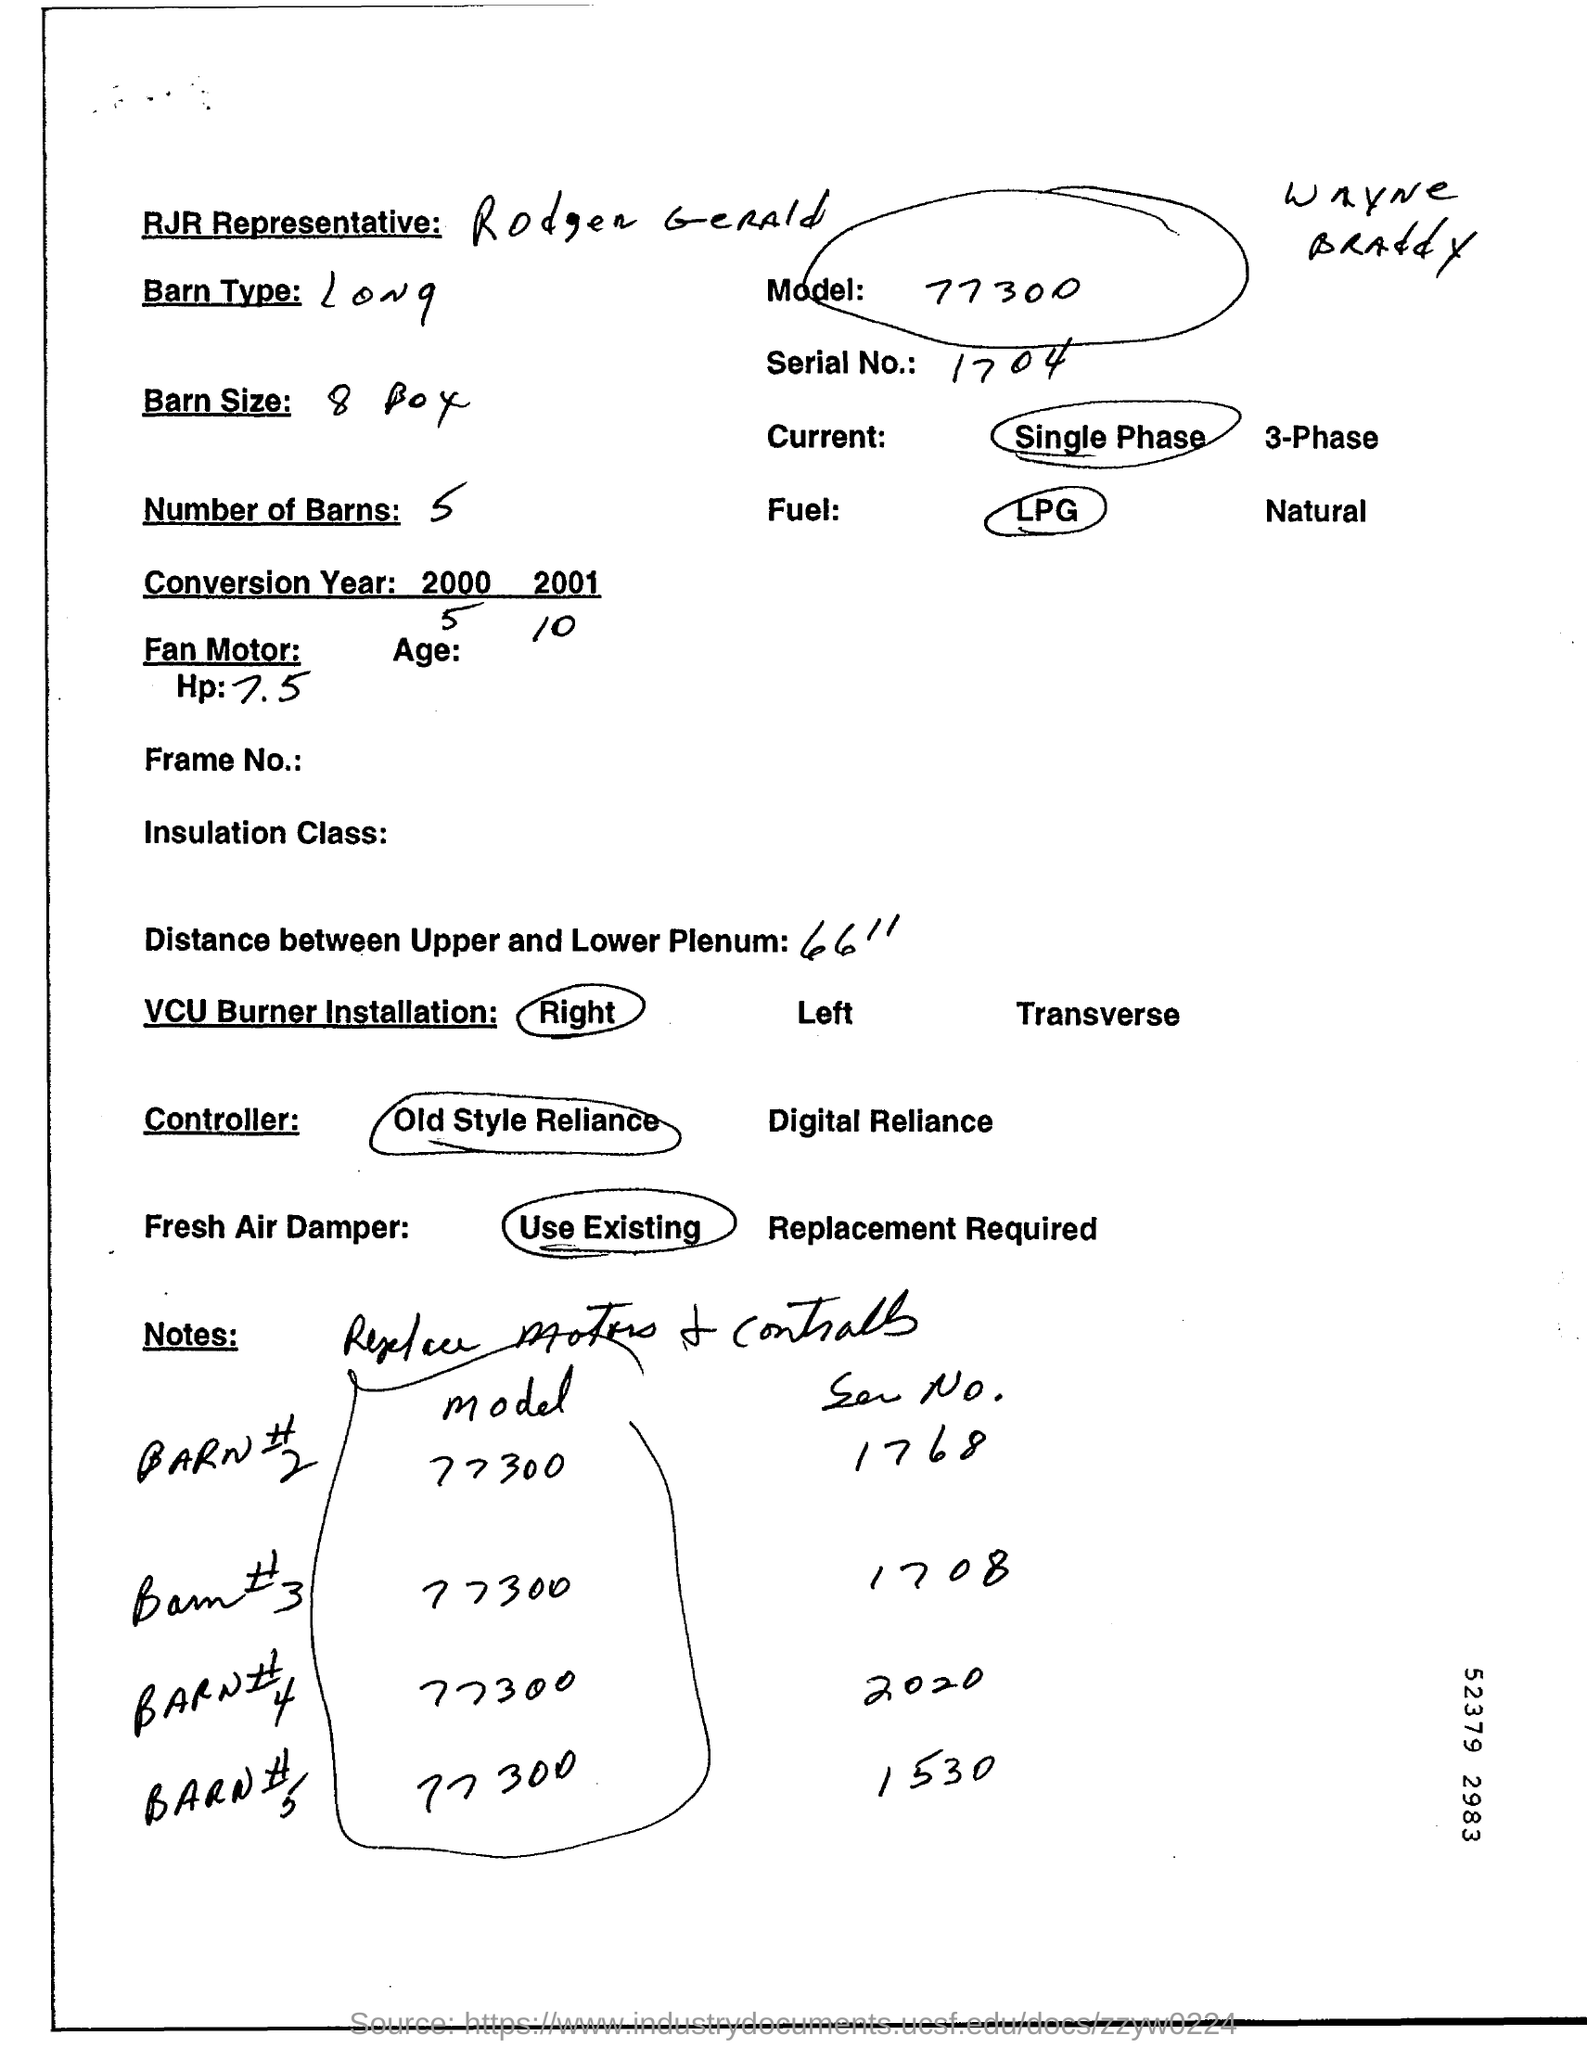Give some essential details in this illustration. What is the serial number?" the supervisor asked. "It is 1704," the employee replied. The distance between the Upper and Lower Plenum is approximately 66 feet. Rodger Gerald is the RJR Representative. 